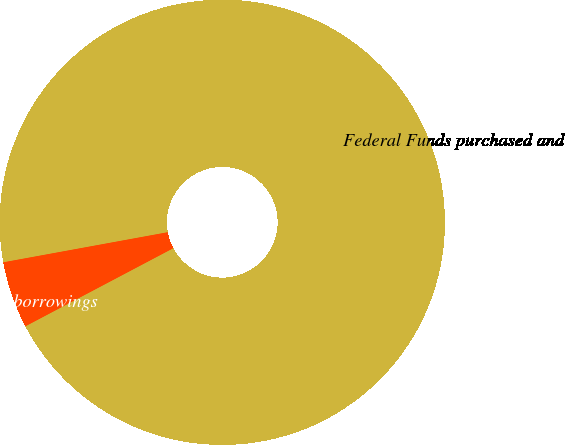<chart> <loc_0><loc_0><loc_500><loc_500><pie_chart><fcel>Federal Funds purchased and<fcel>Other short-term borrowings<nl><fcel>95.15%<fcel>4.85%<nl></chart> 